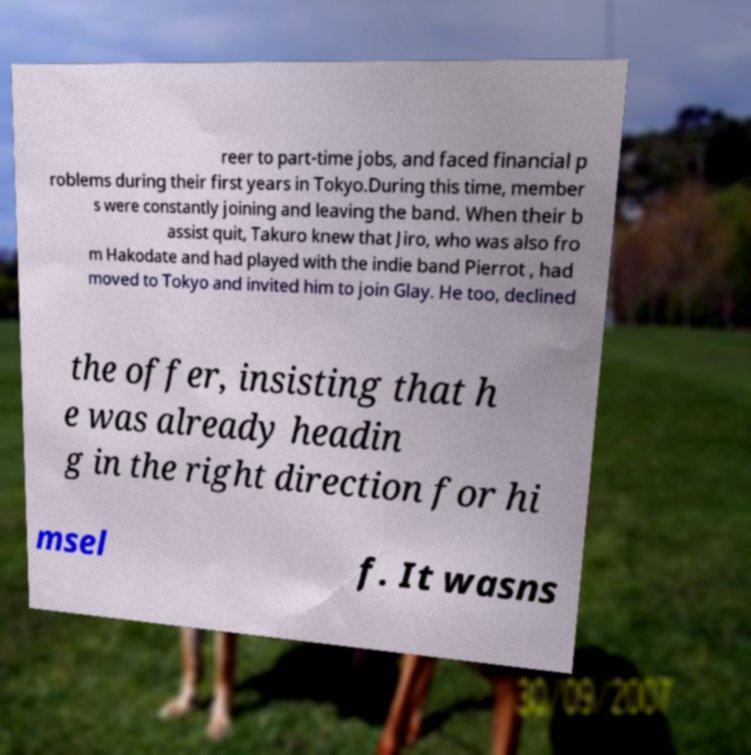For documentation purposes, I need the text within this image transcribed. Could you provide that? reer to part-time jobs, and faced financial p roblems during their first years in Tokyo.During this time, member s were constantly joining and leaving the band. When their b assist quit, Takuro knew that Jiro, who was also fro m Hakodate and had played with the indie band Pierrot , had moved to Tokyo and invited him to join Glay. He too, declined the offer, insisting that h e was already headin g in the right direction for hi msel f. It wasns 